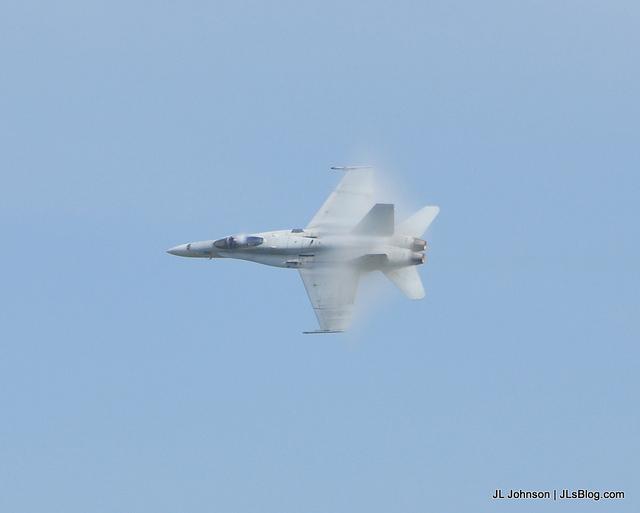How is the sky?
Quick response, please. Clear. Does this look like a passenger plane?
Concise answer only. No. What country is the plane from?
Answer briefly. Usa. Is this a military aircraft?
Be succinct. Yes. Which photographer took this image?
Give a very brief answer. Jl johnson. 